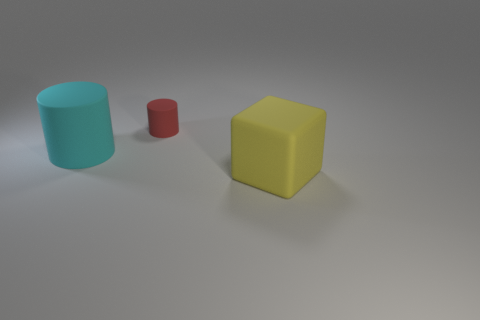Subtract all green blocks. Subtract all green balls. How many blocks are left? 1 Add 2 large cyan spheres. How many objects exist? 5 Subtract all cylinders. How many objects are left? 1 Subtract all big purple metal blocks. Subtract all big objects. How many objects are left? 1 Add 3 rubber things. How many rubber things are left? 6 Add 2 big yellow things. How many big yellow things exist? 3 Subtract 1 cyan cylinders. How many objects are left? 2 